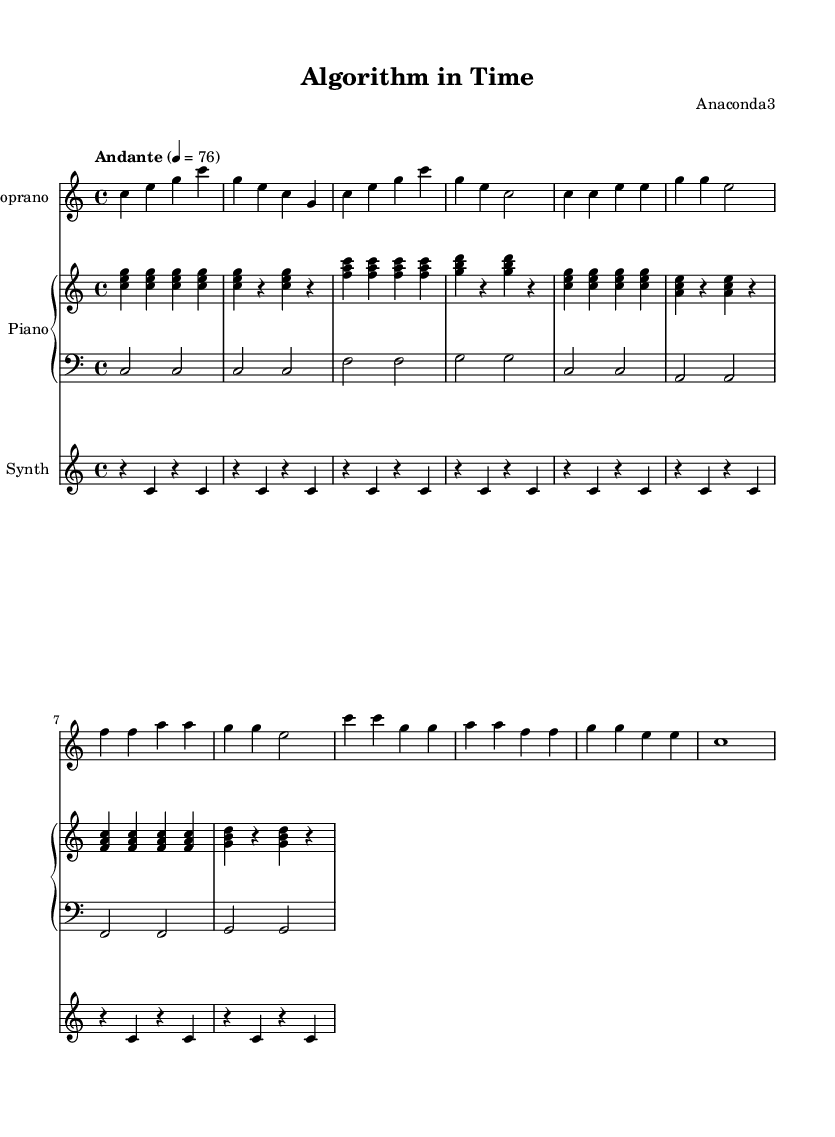What is the key signature of this music? The key signature is C major, which is indicated directly in the global section of the sheet music. C major has no sharps or flats.
Answer: C major What is the time signature of this music? The time signature is 4/4, which is also shown in the global section. It indicates that there are four beats in each measure and the quarter note gets one beat.
Answer: 4/4 What is the tempo marking of this piece? The tempo marking is "Andante," which suggests a moderately slow tempo. This is provided in the global section along with the metronome indication.
Answer: Andante How many notes are in the first measure of the soprano voice? The first measure of the soprano voice has four notes: C, E, G, and C. This can be counted by looking at the notes in that measure.
Answer: 4 In which section does the chorus occur in the lyrics? The chorus occurs after the verse in the lyric section, as indicated by the structure shown in the score. The lyrics under the "sopranoVoice" clearly differentiate between the verse and chorus.
Answer: After the verse What type of chords are used in the piano right hand during the intro? The chords used in the piano right hand during the intro are triads (C major and F major). This can be identified by analyzing the notes played together at each measure in the right-hand piano part.
Answer: Triads How does the synthesizer part contribute to the overall texture? The synthesizer part plays sustained notes, creating a drone-like backdrop, which adds depth and maintains the minimalist texture throughout the composition. This is discerned by the rhythmic and harmonic consistency of the synthesizer in relation to the other parts.
Answer: Drone-like backdrop 